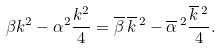Convert formula to latex. <formula><loc_0><loc_0><loc_500><loc_500>\beta k ^ { 2 } - \alpha ^ { 2 } \frac { k ^ { 2 } } { 4 } = \overline { \beta } \, { \overline { k } } { \, } ^ { 2 } - { \overline { \alpha } } { \, } ^ { 2 } \frac { { \overline { k } } { \, } ^ { 2 } } { 4 } .</formula> 